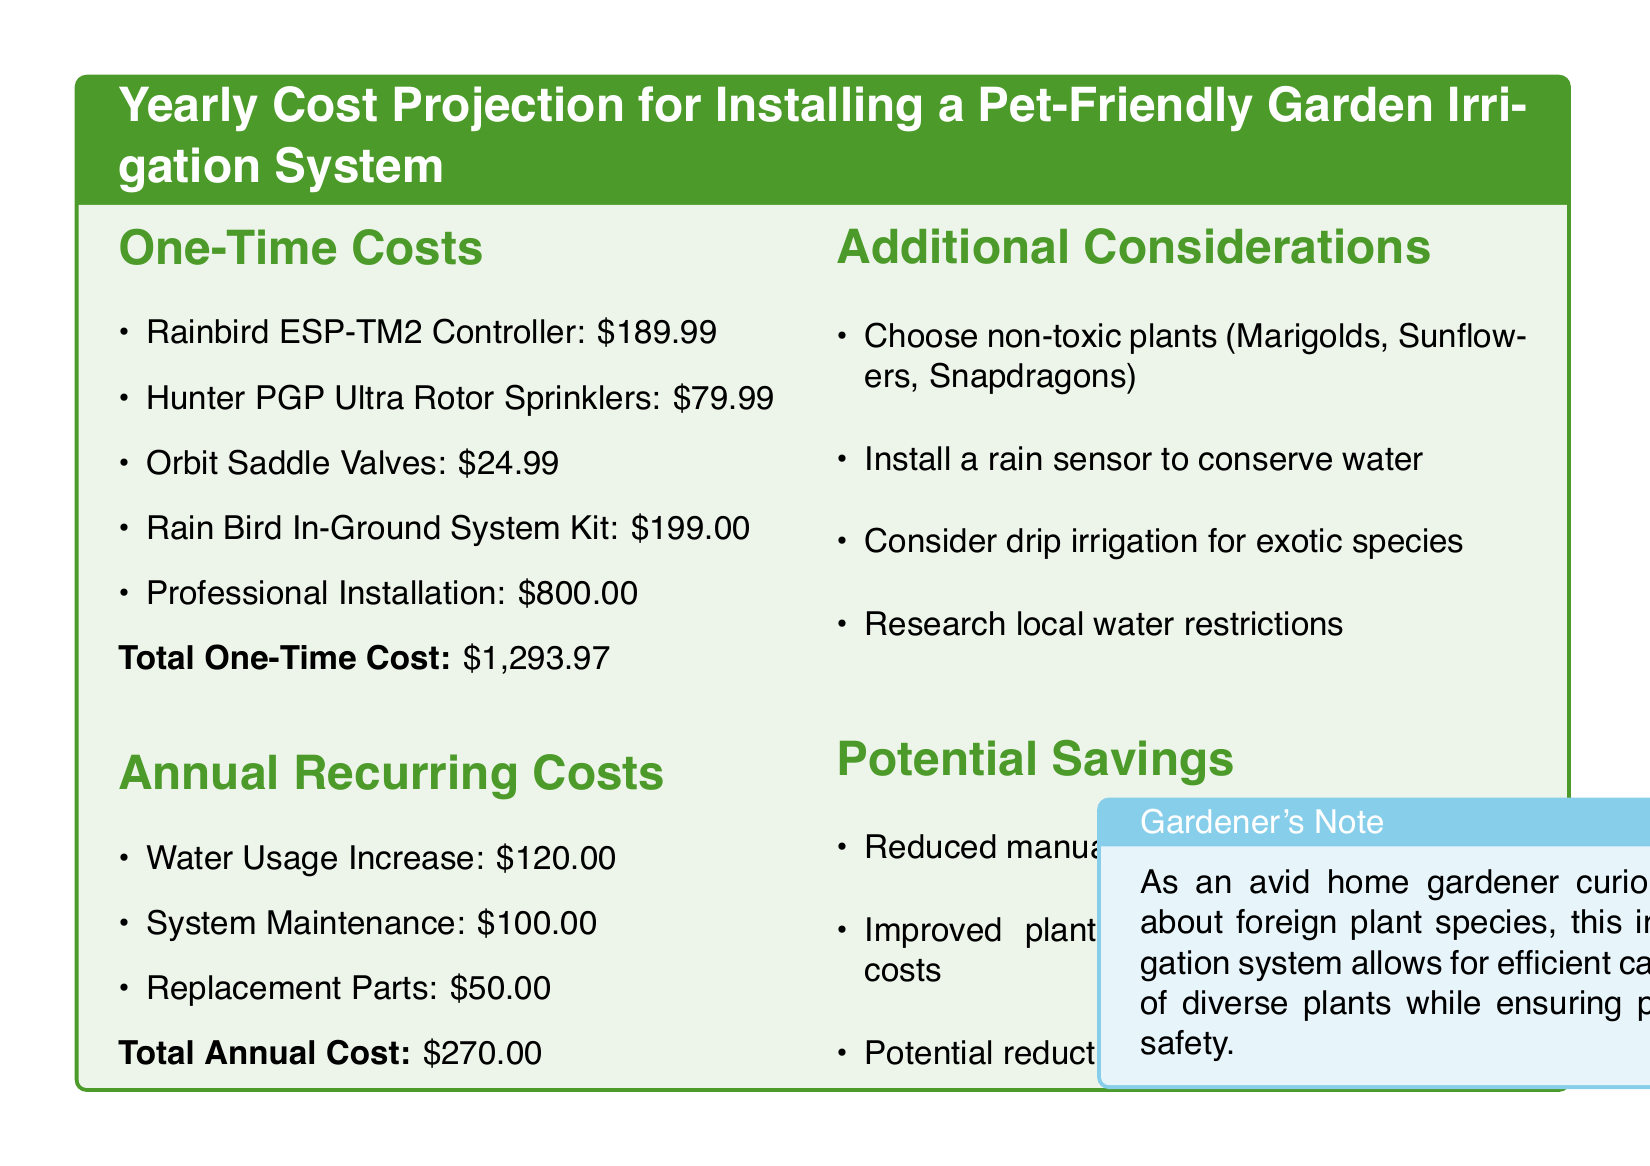what is the total one-time cost? The total one-time cost is the sum of all one-time costs listed in the document. The total is $1,293.97.
Answer: $1,293.97 what is the annual water usage increase cost? The document specifies the annual recurring cost attributed to water usage increase as $120.00.
Answer: $120.00 how much is the professional installation cost? The professional installation cost is explicitly stated in the one-time costs section of the document as $800.00.
Answer: $800.00 what are two non-toxic plants mentioned? The document lists Marigolds and Sunflowers as examples of non-toxic plants suitable for a pet-friendly garden.
Answer: Marigolds, Sunflowers what is the total annual cost? The total annual cost is calculated by summing up all the annual recurring costs in the document, which is $270.00.
Answer: $270.00 what feature is suggested to conserve water? A rain sensor is recommended in the document to help conserve water usage in the irrigation system.
Answer: rain sensor which irrigation type is suggested for exotic species? The document advises considering drip irrigation for exotic plant species to ensure proper care.
Answer: drip irrigation what is one potential savings listed in the document? One potential saving mentioned in the document is reduced manual watering time, which reflects efficiency gained with the irrigation system.
Answer: reduced manual watering time 